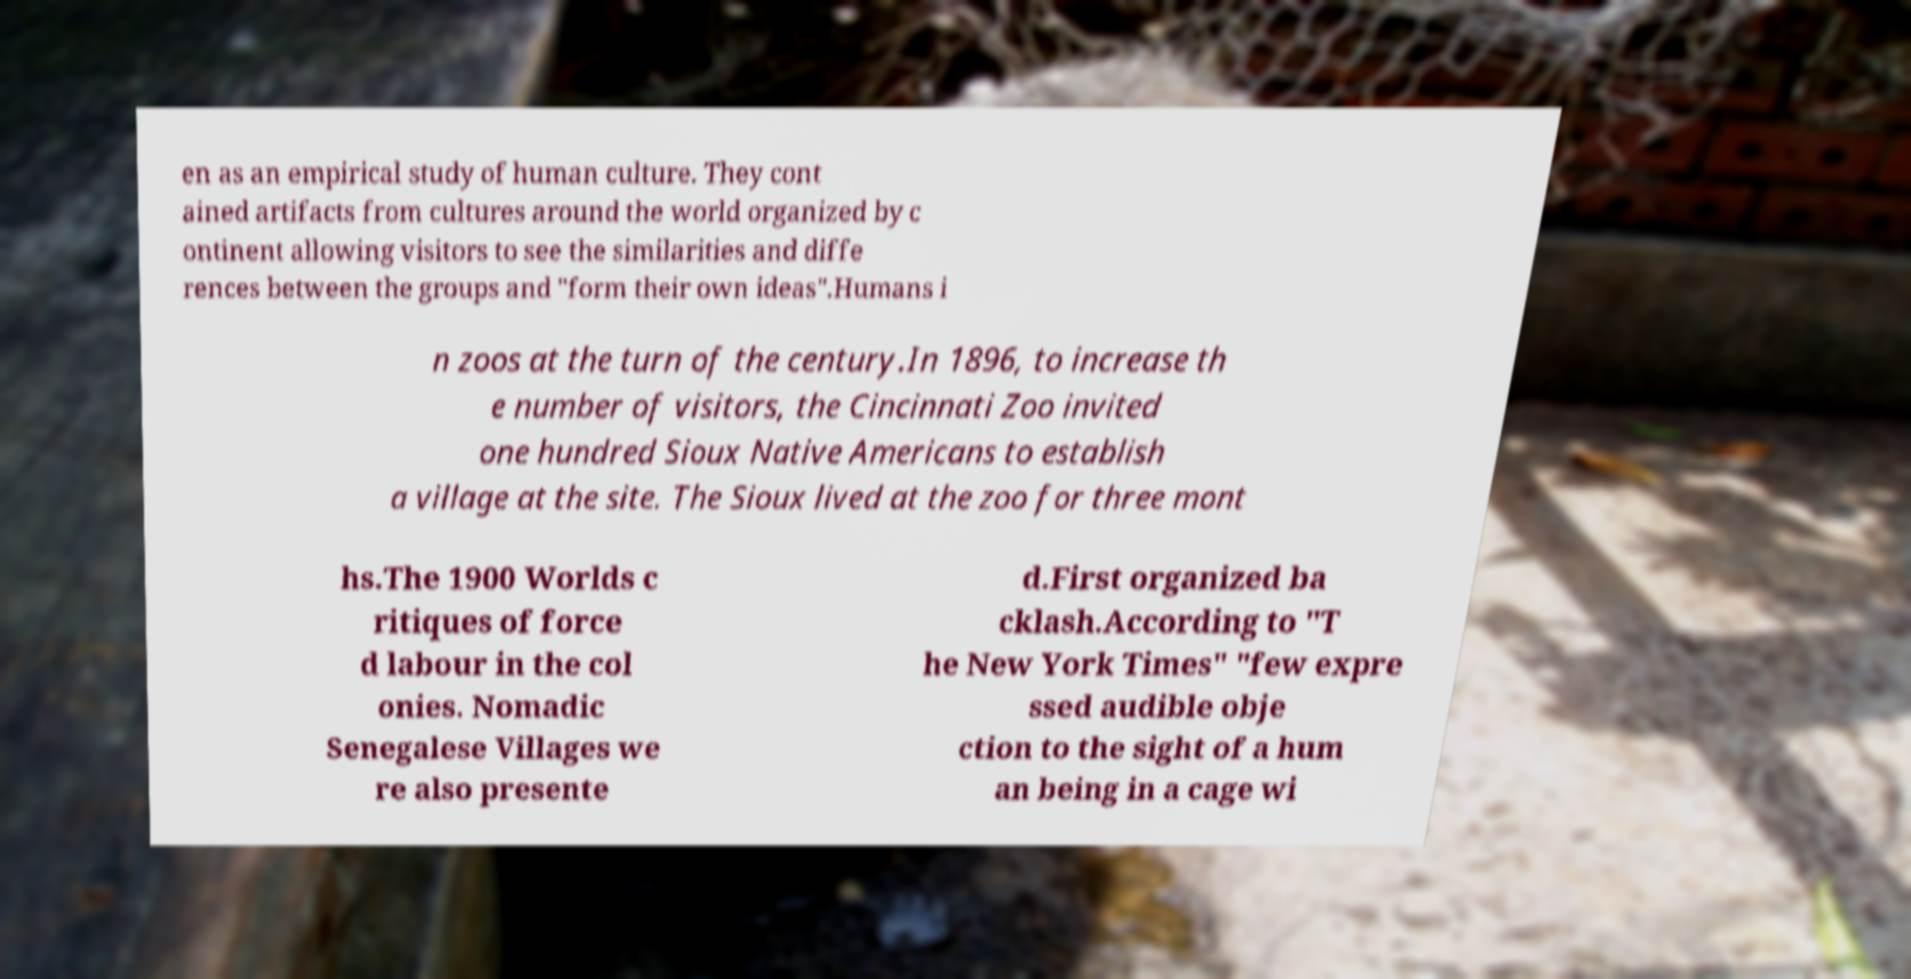Please identify and transcribe the text found in this image. en as an empirical study of human culture. They cont ained artifacts from cultures around the world organized by c ontinent allowing visitors to see the similarities and diffe rences between the groups and "form their own ideas".Humans i n zoos at the turn of the century.In 1896, to increase th e number of visitors, the Cincinnati Zoo invited one hundred Sioux Native Americans to establish a village at the site. The Sioux lived at the zoo for three mont hs.The 1900 Worlds c ritiques of force d labour in the col onies. Nomadic Senegalese Villages we re also presente d.First organized ba cklash.According to "T he New York Times" "few expre ssed audible obje ction to the sight of a hum an being in a cage wi 